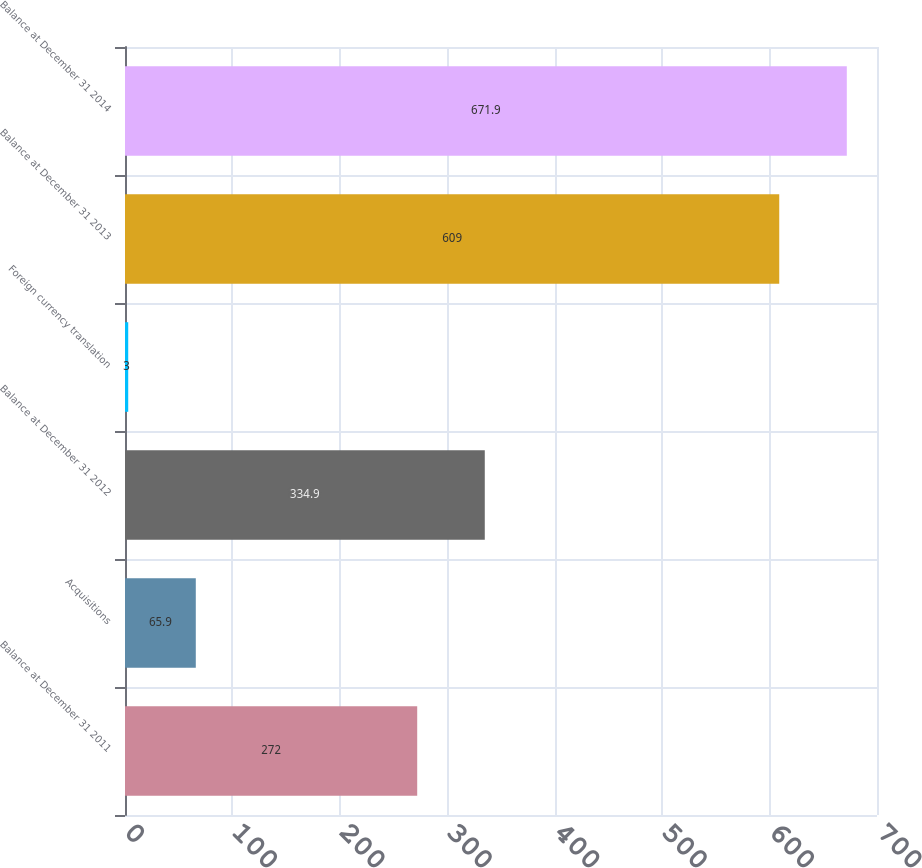Convert chart to OTSL. <chart><loc_0><loc_0><loc_500><loc_500><bar_chart><fcel>Balance at December 31 2011<fcel>Acquisitions<fcel>Balance at December 31 2012<fcel>Foreign currency translation<fcel>Balance at December 31 2013<fcel>Balance at December 31 2014<nl><fcel>272<fcel>65.9<fcel>334.9<fcel>3<fcel>609<fcel>671.9<nl></chart> 